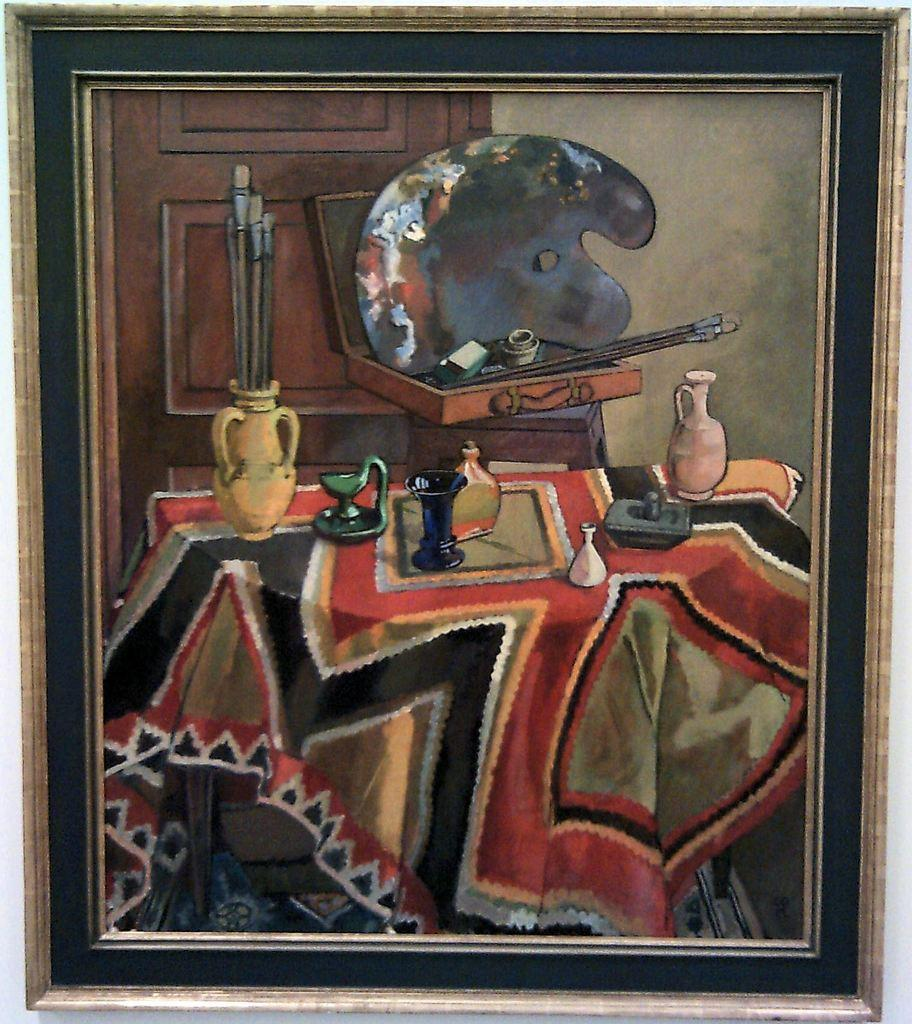What is the main subject of the image? There is a painting in the image. How is the painting displayed? The painting is in a frame. What type of material is used for the objects in the image? There are wooden objects in the image. What type of material is used for the cloth in the image? There is cloth in the image. Can you describe any other unspecified objects in the image? There are other unspecified objects in the image, but their details are not provided. How does the bear in the image react to the cough? There is no bear or cough present in the image; it only features a painting, a frame, wooden objects, cloth, and other unspecified objects. 